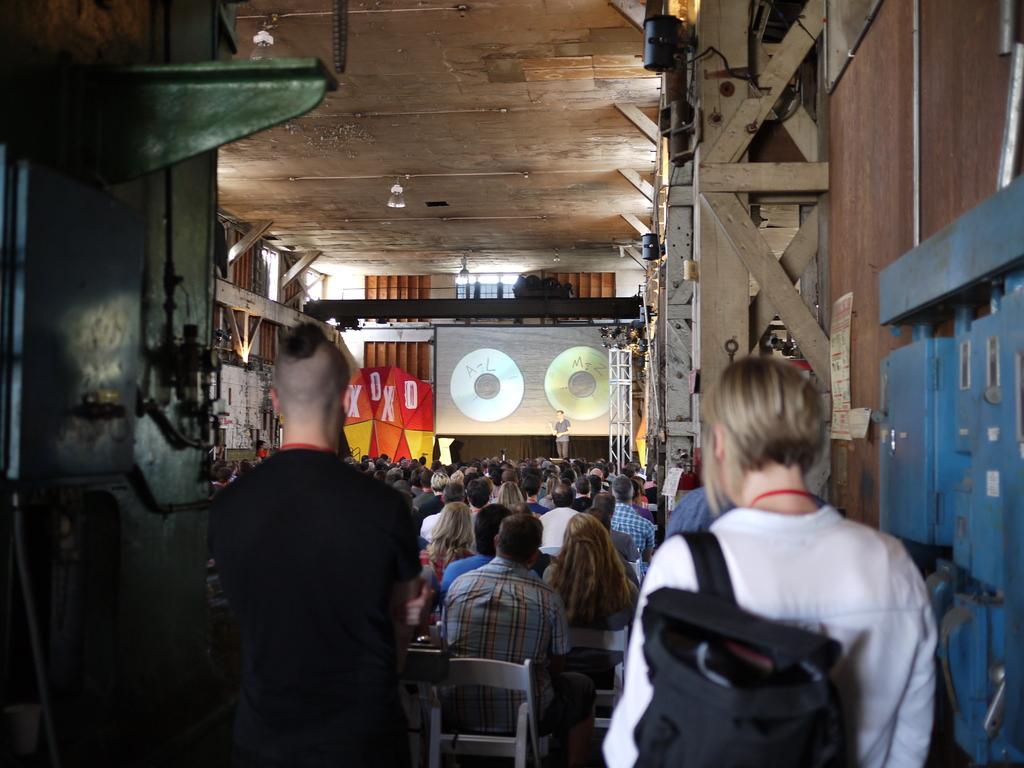In one or two sentences, can you explain what this image depicts? In this picture we can see some persons sitting on the chairs. Here we can see a man who is standing on the stage. This is screen. And these are the lights. 